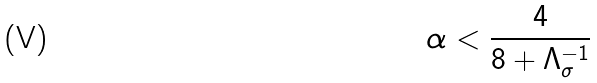Convert formula to latex. <formula><loc_0><loc_0><loc_500><loc_500>\alpha < \frac { 4 } { 8 + \Lambda _ { \sigma } ^ { - 1 } }</formula> 